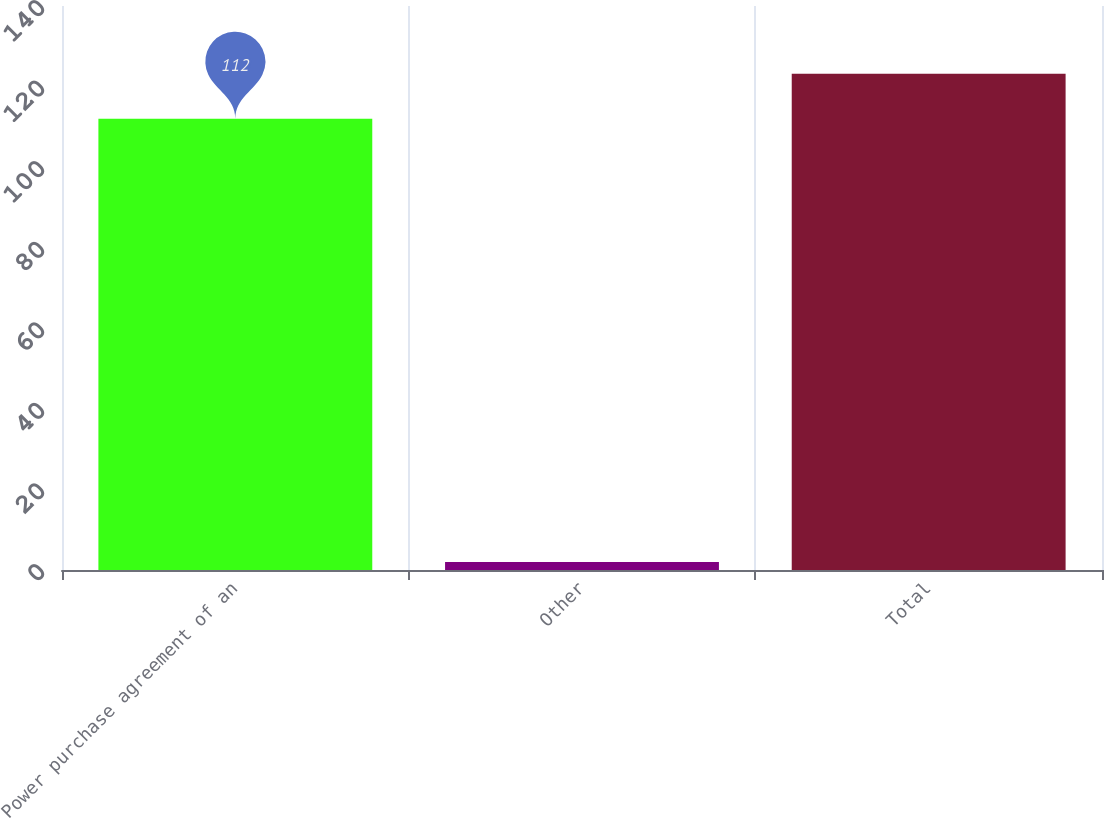Convert chart. <chart><loc_0><loc_0><loc_500><loc_500><bar_chart><fcel>Power purchase agreement of an<fcel>Other<fcel>Total<nl><fcel>112<fcel>2<fcel>123.2<nl></chart> 